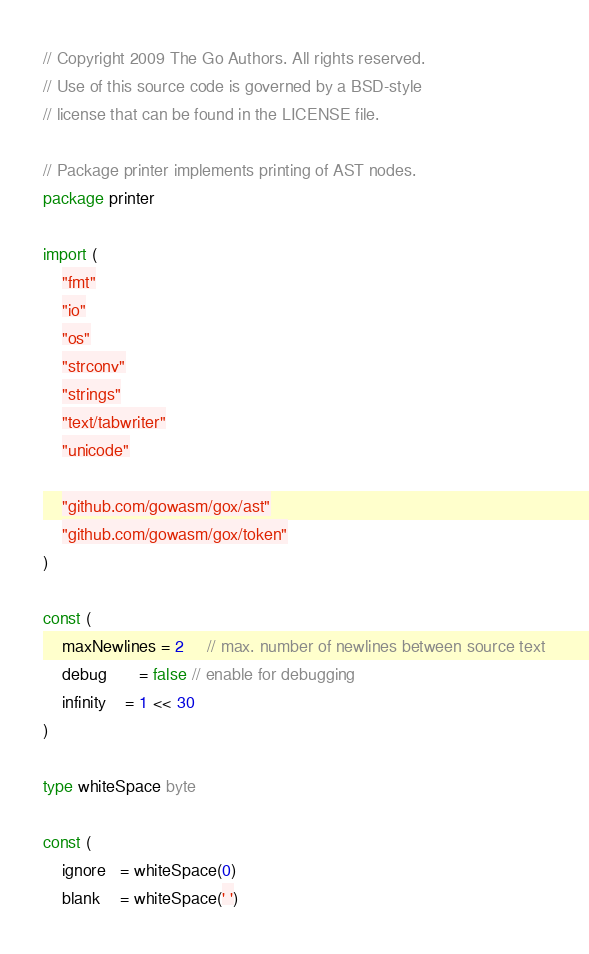Convert code to text. <code><loc_0><loc_0><loc_500><loc_500><_Go_>// Copyright 2009 The Go Authors. All rights reserved.
// Use of this source code is governed by a BSD-style
// license that can be found in the LICENSE file.

// Package printer implements printing of AST nodes.
package printer

import (
	"fmt"
	"io"
	"os"
	"strconv"
	"strings"
	"text/tabwriter"
	"unicode"

	"github.com/gowasm/gox/ast"
	"github.com/gowasm/gox/token"
)

const (
	maxNewlines = 2     // max. number of newlines between source text
	debug       = false // enable for debugging
	infinity    = 1 << 30
)

type whiteSpace byte

const (
	ignore   = whiteSpace(0)
	blank    = whiteSpace(' ')</code> 